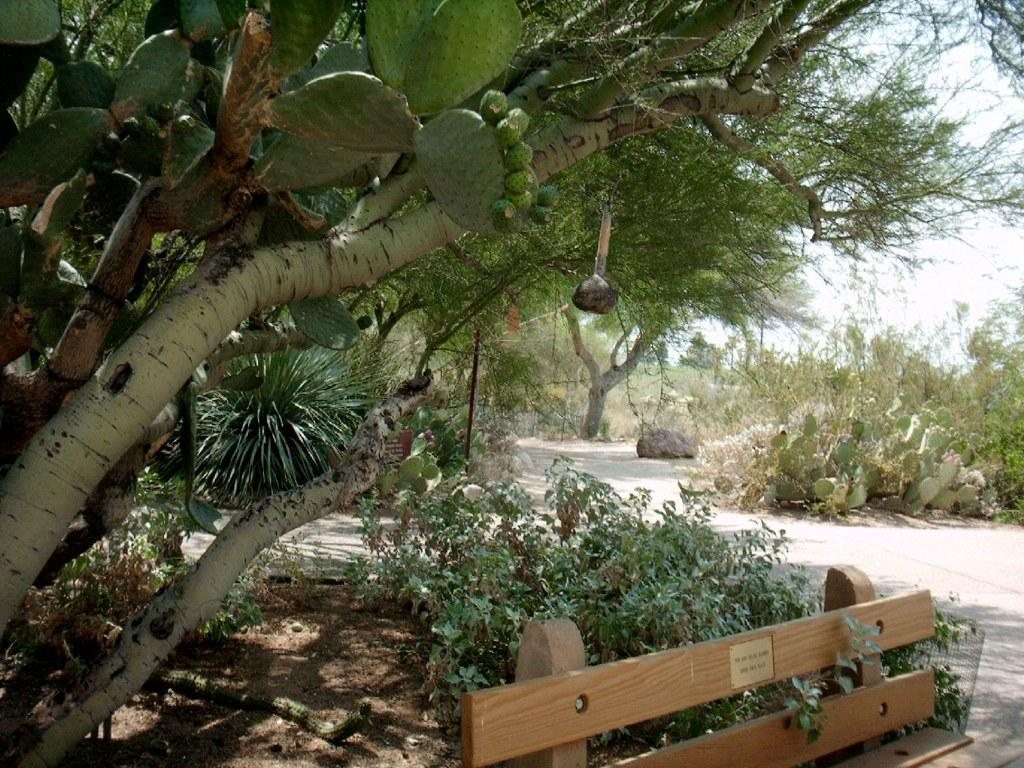What is located at the bottom of the image? There is a bench at the bottom of the image. What else can be seen at the bottom of the image? There are plants at the bottom of the image. What is visible in the background of the image? There are trees and the sky visible in the background of the image. What type of orange fruit can be seen growing on the trees in the image? There is no orange fruit visible in the image; the trees are not specified as fruit-bearing trees. What type of stone is used to construct the bench in the image? There is no information provided about the material used to construct the bench in the image. 